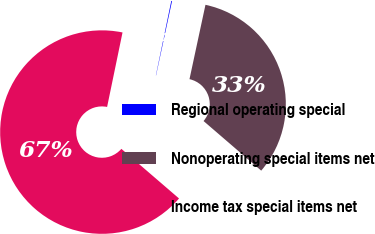<chart> <loc_0><loc_0><loc_500><loc_500><pie_chart><fcel>Regional operating special<fcel>Nonoperating special items net<fcel>Income tax special items net<nl><fcel>0.12%<fcel>32.94%<fcel>66.94%<nl></chart> 